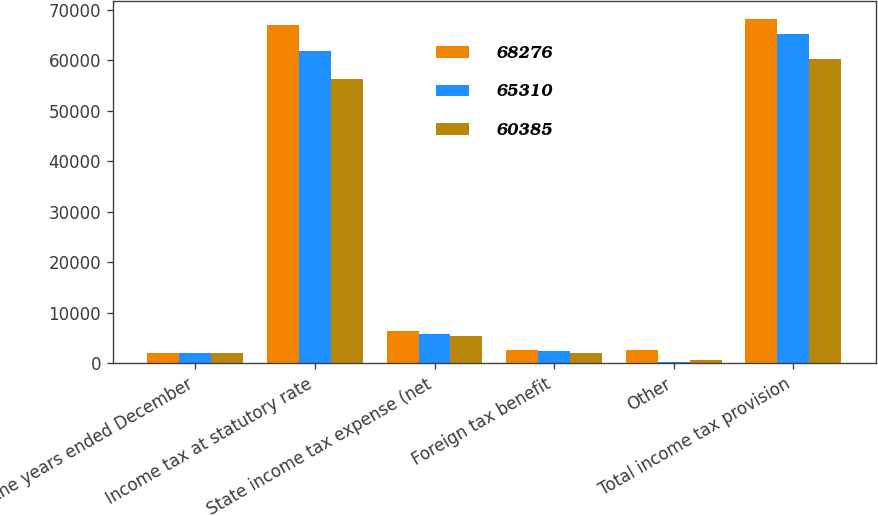Convert chart. <chart><loc_0><loc_0><loc_500><loc_500><stacked_bar_chart><ecel><fcel>For the years ended December<fcel>Income tax at statutory rate<fcel>State income tax expense (net<fcel>Foreign tax benefit<fcel>Other<fcel>Total income tax provision<nl><fcel>68276<fcel>2013<fcel>67063<fcel>6498<fcel>2661<fcel>2624<fcel>68276<nl><fcel>65310<fcel>2012<fcel>61825<fcel>5835<fcel>2560<fcel>210<fcel>65310<nl><fcel>60385<fcel>2011<fcel>56384<fcel>5477<fcel>2109<fcel>633<fcel>60385<nl></chart> 